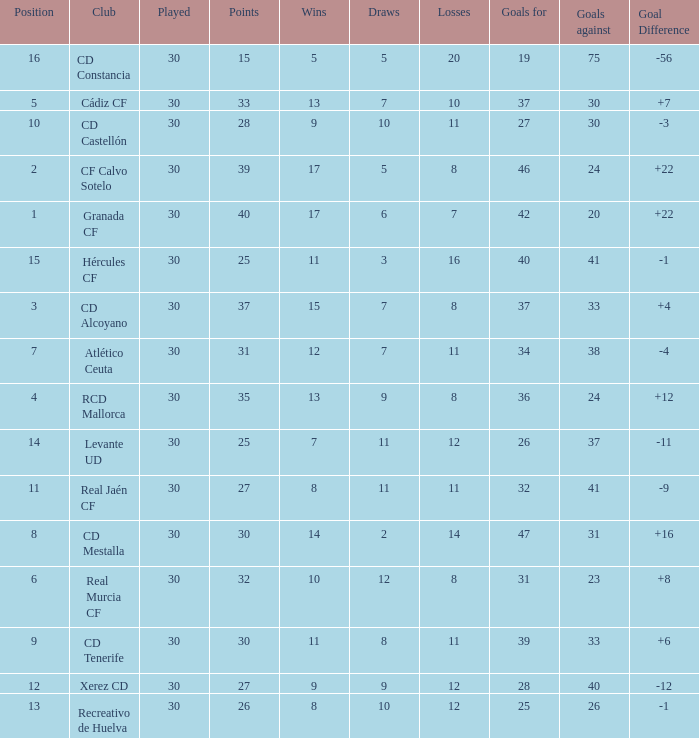Which Wins have a Goal Difference larger than 12, and a Club of granada cf, and Played larger than 30? None. 